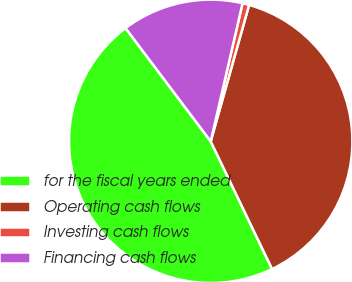Convert chart to OTSL. <chart><loc_0><loc_0><loc_500><loc_500><pie_chart><fcel>for the fiscal years ended<fcel>Operating cash flows<fcel>Investing cash flows<fcel>Financing cash flows<nl><fcel>46.87%<fcel>38.5%<fcel>0.76%<fcel>13.87%<nl></chart> 